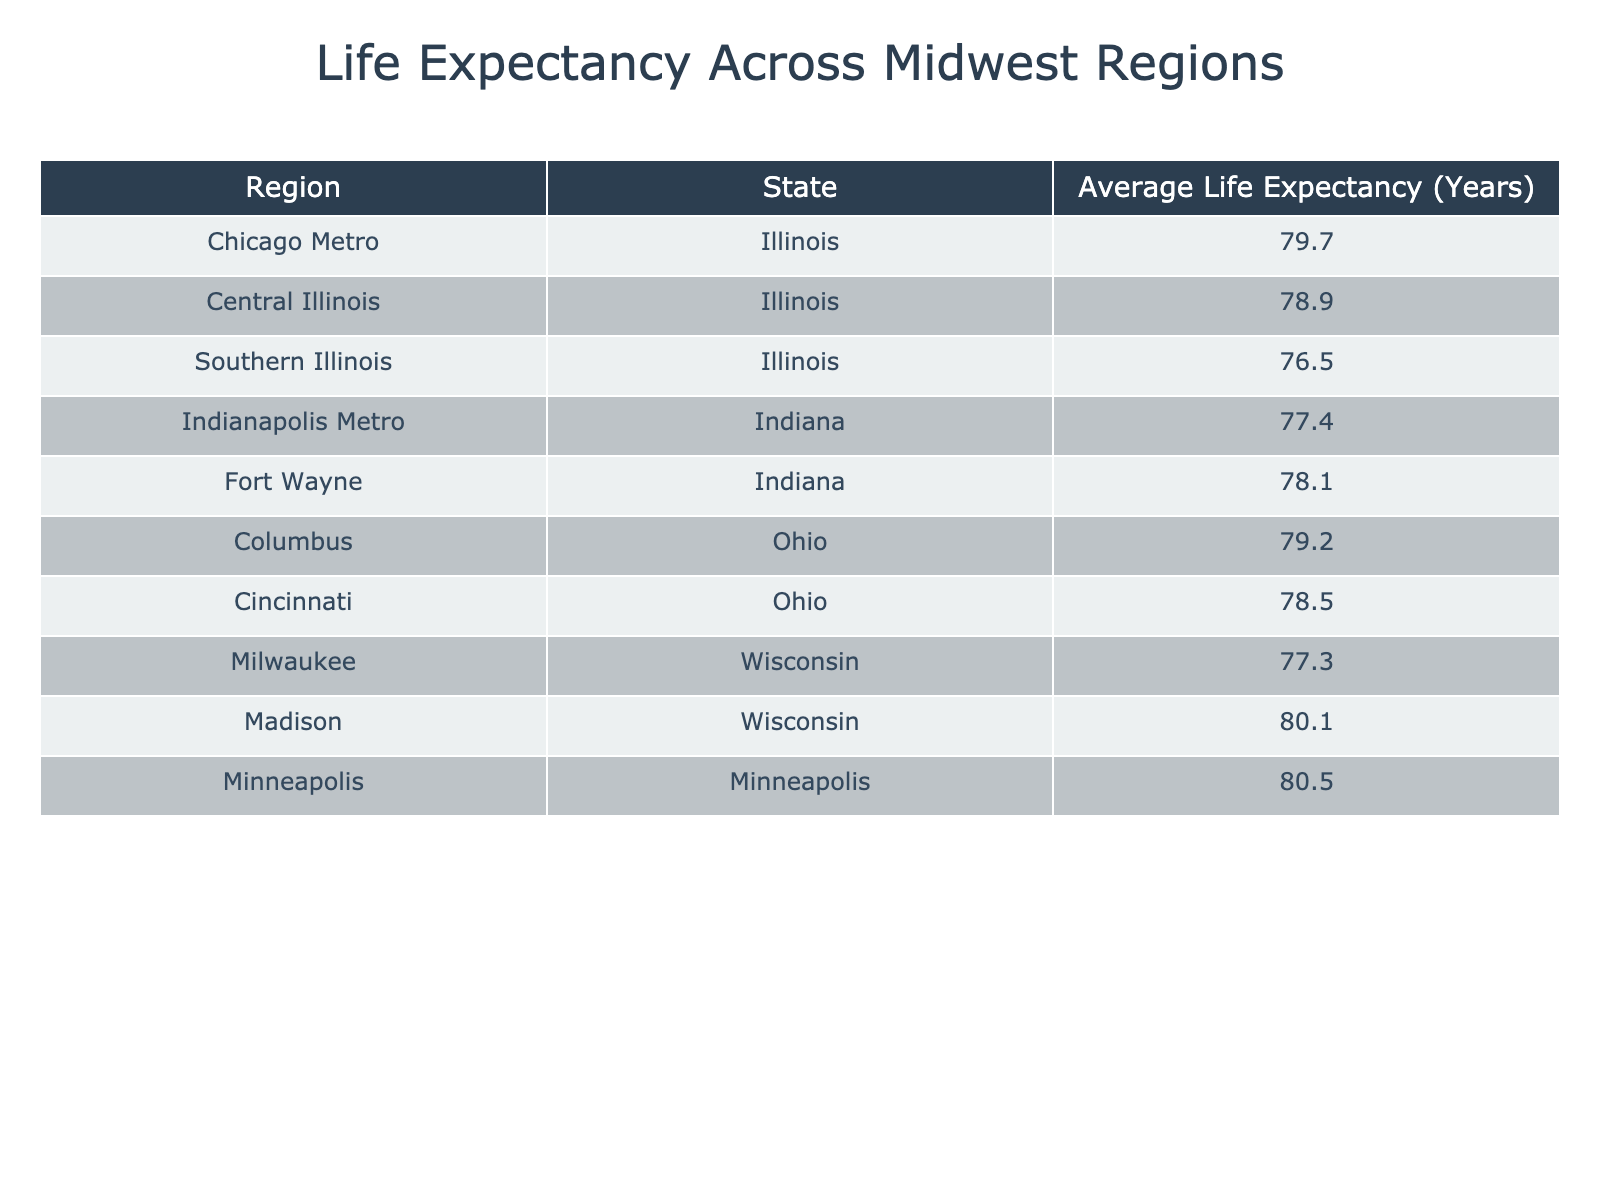What is the average life expectancy for the Southern Illinois region? The table explicitly states that the average life expectancy for Southern Illinois is 76.5 years.
Answer: 76.5 Which region in Illinois has the highest average life expectancy? Looking at the table, the region with the highest average life expectancy in Illinois is the Chicago Metro with 79.7 years.
Answer: Chicago Metro Is the average life expectancy in Madison, Wisconsin greater than 80 years? The table shows that the average life expectancy in Madison, Wisconsin is 80.1 years, which is indeed greater than 80.
Answer: Yes What is the difference in average life expectancy between Indianapolis Metro and Southern Illinois? The average life expectancy for Indianapolis Metro is 77.4 years and for Southern Illinois is 76.5 years. The difference is 77.4 - 76.5 = 0.9 years.
Answer: 0.9 What is the combined average life expectancy of the regions in Ohio? The regions listed for Ohio are Columbus with 79.2 years and Cincinnati with 78.5 years. The total is 79.2 + 78.5 = 157.7 years, and the average is 157.7 / 2 = 78.85 years.
Answer: 78.85 Which state has the lowest average life expectancy in this table? By searching through the table, Southern Illinois has the lowest average life expectancy at 76.5 years, indicating it is the state with the lowest figure among all entries.
Answer: Illinois Is the average life expectancy in Chicago Metro higher than the average for all regions displayed? The average life expectancy in Chicago Metro is 79.7 years. To determine if this is higher than the overall average of all regions, we calculate the average of the data provided, which is approximately 78.8 years. Since 79.7 is greater than 78.8, the answer is yes.
Answer: Yes What is the average life expectancy for the regions in Illinois listed in the table? Summing the life expectancies of Chicago Metro (79.7), Central Illinois (78.9), and Southern Illinois (76.5) gives us 79.7 + 78.9 + 76.5 = 235.1 years. Dividing this by 3 yields an average of approximately 78.37 years.
Answer: 78.37 